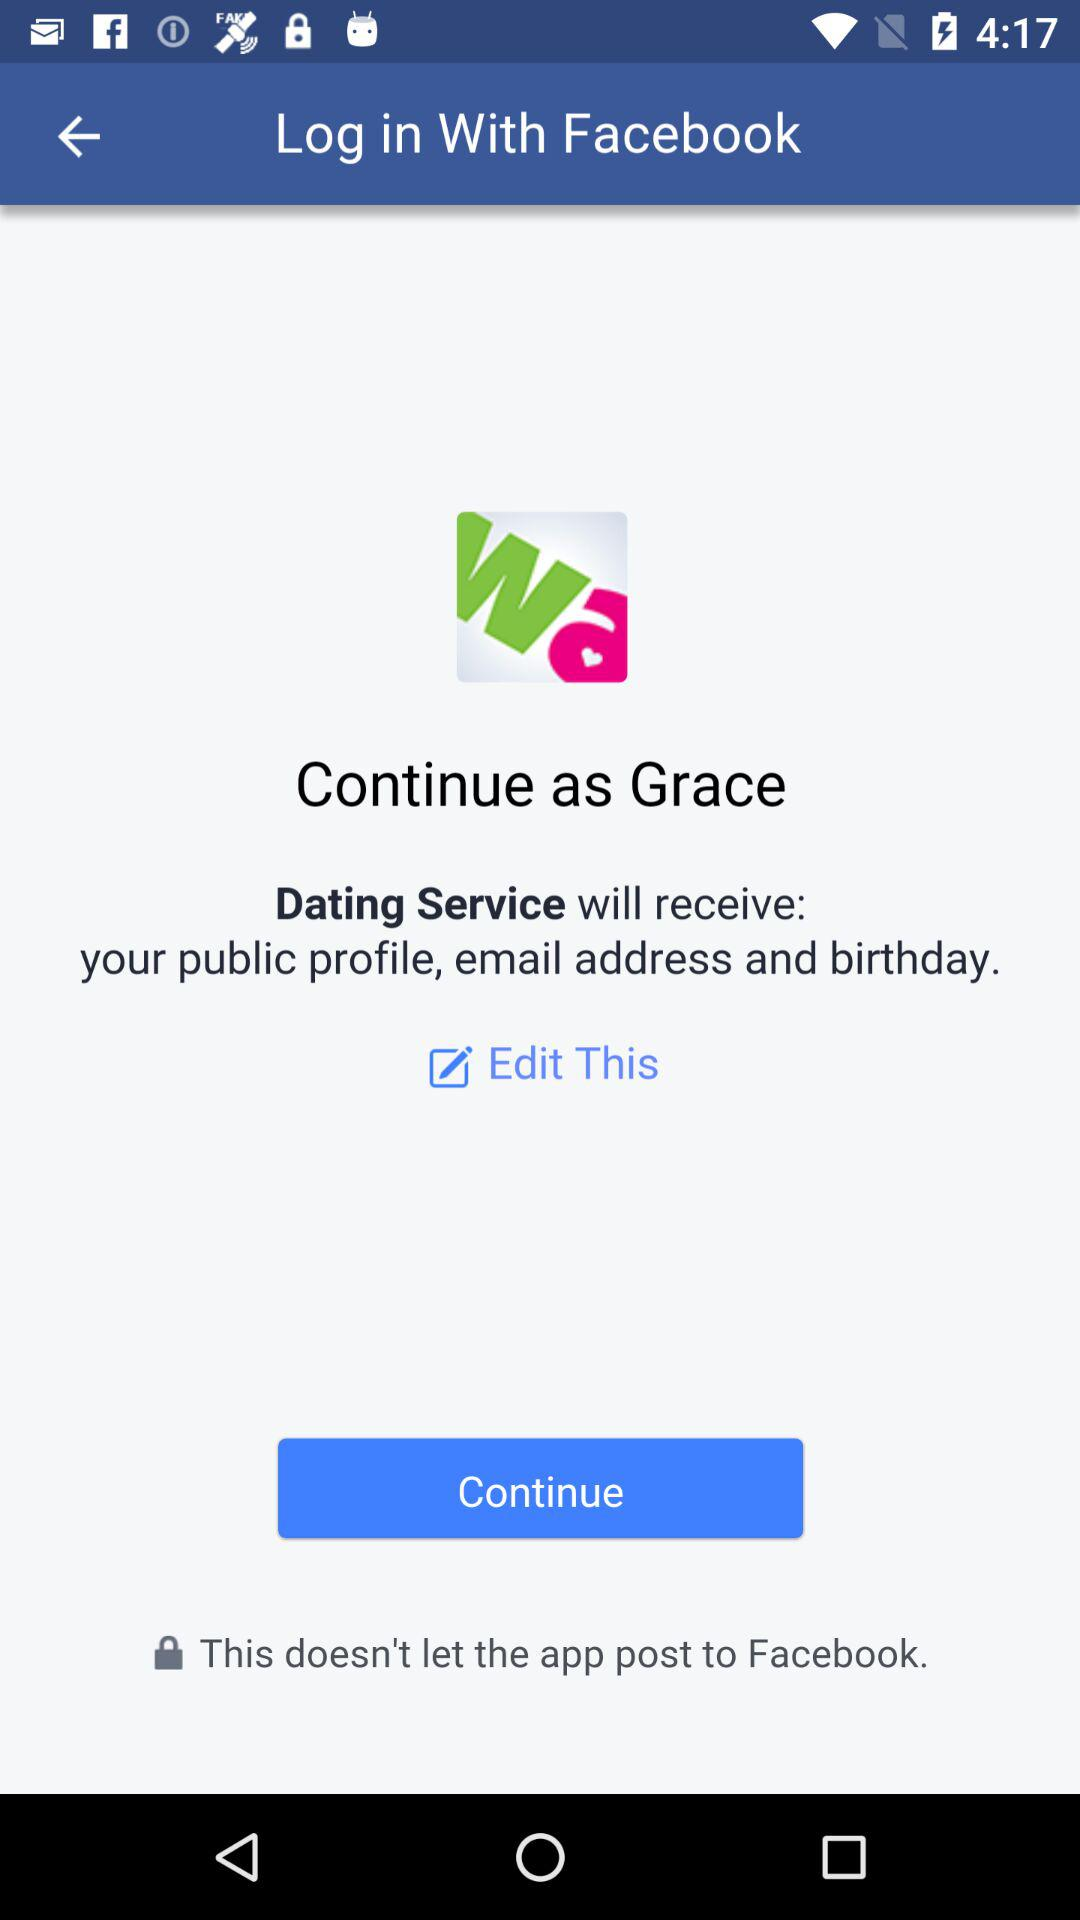What application is asking for permission? The application asking for permission is "Dating Service". 